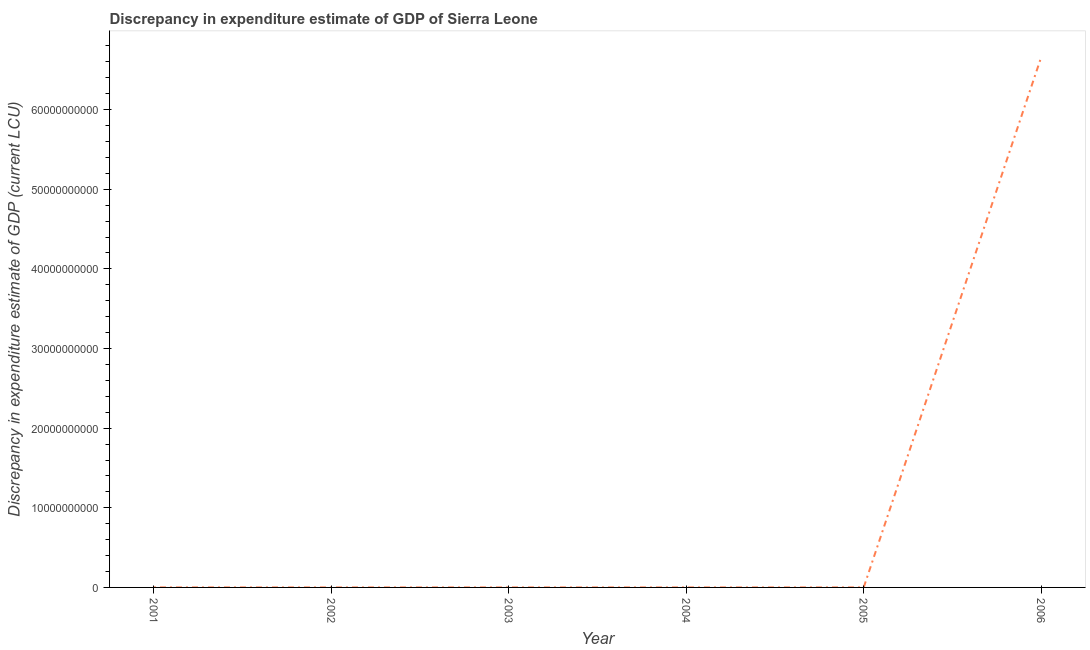What is the discrepancy in expenditure estimate of gdp in 2005?
Give a very brief answer. 2.00e+06. Across all years, what is the maximum discrepancy in expenditure estimate of gdp?
Ensure brevity in your answer.  6.66e+1. Across all years, what is the minimum discrepancy in expenditure estimate of gdp?
Keep it short and to the point. 0. What is the sum of the discrepancy in expenditure estimate of gdp?
Your answer should be compact. 6.66e+1. What is the difference between the discrepancy in expenditure estimate of gdp in 2001 and 2006?
Make the answer very short. -6.66e+1. What is the average discrepancy in expenditure estimate of gdp per year?
Offer a terse response. 1.11e+1. What is the median discrepancy in expenditure estimate of gdp?
Keep it short and to the point. 1.50e+06. In how many years, is the discrepancy in expenditure estimate of gdp greater than 64000000000 LCU?
Provide a succinct answer. 1. What is the ratio of the discrepancy in expenditure estimate of gdp in 2001 to that in 2006?
Make the answer very short. 3.0043484778078083e-5. What is the difference between the highest and the second highest discrepancy in expenditure estimate of gdp?
Your answer should be compact. 6.66e+1. Is the sum of the discrepancy in expenditure estimate of gdp in 2001 and 2002 greater than the maximum discrepancy in expenditure estimate of gdp across all years?
Make the answer very short. No. What is the difference between the highest and the lowest discrepancy in expenditure estimate of gdp?
Make the answer very short. 6.66e+1. Does the discrepancy in expenditure estimate of gdp monotonically increase over the years?
Give a very brief answer. No. How many lines are there?
Ensure brevity in your answer.  1. How many years are there in the graph?
Make the answer very short. 6. What is the difference between two consecutive major ticks on the Y-axis?
Ensure brevity in your answer.  1.00e+1. Does the graph contain grids?
Make the answer very short. No. What is the title of the graph?
Your answer should be compact. Discrepancy in expenditure estimate of GDP of Sierra Leone. What is the label or title of the X-axis?
Ensure brevity in your answer.  Year. What is the label or title of the Y-axis?
Provide a short and direct response. Discrepancy in expenditure estimate of GDP (current LCU). What is the Discrepancy in expenditure estimate of GDP (current LCU) of 2001?
Give a very brief answer. 2.00e+06. What is the Discrepancy in expenditure estimate of GDP (current LCU) in 2003?
Ensure brevity in your answer.  0. What is the Discrepancy in expenditure estimate of GDP (current LCU) of 2004?
Your answer should be very brief. 0. What is the Discrepancy in expenditure estimate of GDP (current LCU) in 2005?
Your answer should be very brief. 2.00e+06. What is the Discrepancy in expenditure estimate of GDP (current LCU) of 2006?
Make the answer very short. 6.66e+1. What is the difference between the Discrepancy in expenditure estimate of GDP (current LCU) in 2001 and 2002?
Your answer should be compact. 1.00e+06. What is the difference between the Discrepancy in expenditure estimate of GDP (current LCU) in 2001 and 2005?
Your response must be concise. 0. What is the difference between the Discrepancy in expenditure estimate of GDP (current LCU) in 2001 and 2006?
Provide a short and direct response. -6.66e+1. What is the difference between the Discrepancy in expenditure estimate of GDP (current LCU) in 2002 and 2005?
Provide a short and direct response. -1.00e+06. What is the difference between the Discrepancy in expenditure estimate of GDP (current LCU) in 2002 and 2006?
Make the answer very short. -6.66e+1. What is the difference between the Discrepancy in expenditure estimate of GDP (current LCU) in 2005 and 2006?
Your answer should be very brief. -6.66e+1. What is the ratio of the Discrepancy in expenditure estimate of GDP (current LCU) in 2001 to that in 2002?
Give a very brief answer. 2. What is the ratio of the Discrepancy in expenditure estimate of GDP (current LCU) in 2001 to that in 2006?
Your answer should be compact. 0. What is the ratio of the Discrepancy in expenditure estimate of GDP (current LCU) in 2002 to that in 2005?
Ensure brevity in your answer.  0.5. What is the ratio of the Discrepancy in expenditure estimate of GDP (current LCU) in 2002 to that in 2006?
Make the answer very short. 0. What is the ratio of the Discrepancy in expenditure estimate of GDP (current LCU) in 2005 to that in 2006?
Ensure brevity in your answer.  0. 